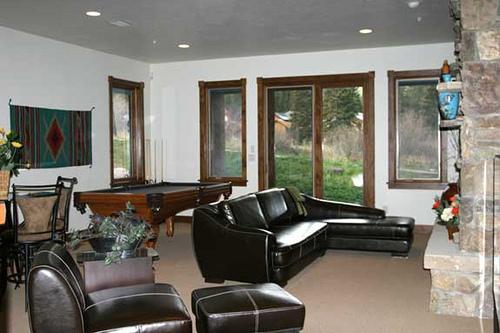Do people play pool here?
Quick response, please. Yes. How many places are there to sit?
Write a very short answer. 4. Is there a leather couch in this room?
Give a very brief answer. Yes. 